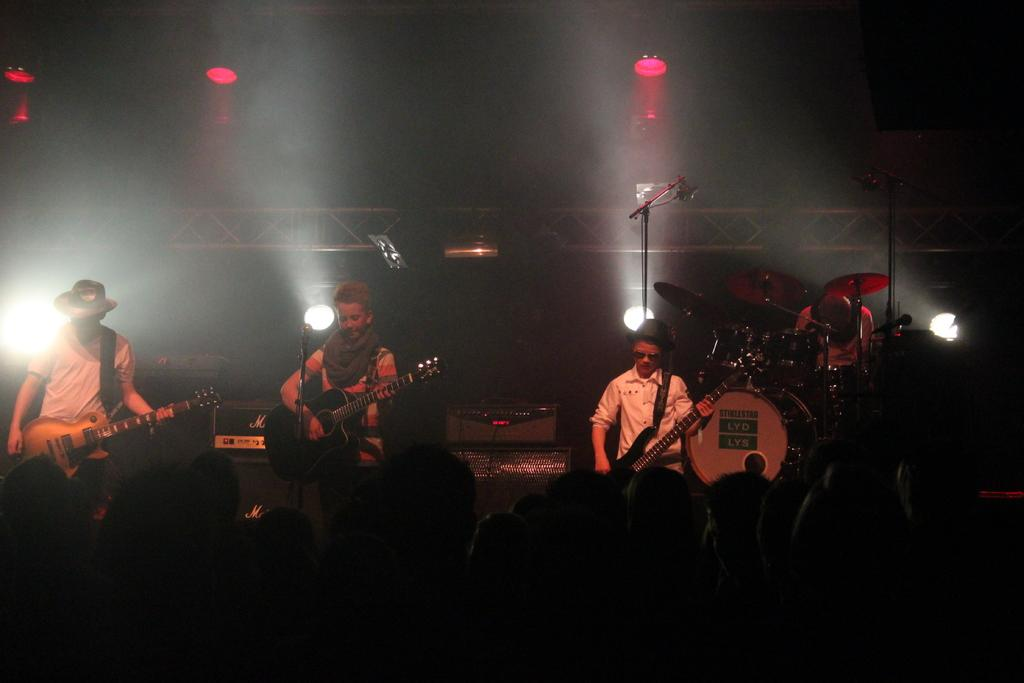How many people are in the image? There are three persons in the image. What are the persons holding in the image? The persons are holding guitars. What are the persons doing with the guitars? The persons are playing the guitars. Can you describe the presence of a microphone in the image? There is a microphone in front of one of the persons. What can be seen in the background of the image? There is a light visible in the background of the image. What type of plants can be seen growing near the persons in the image? There are no plants visible in the image; the focus is on the persons playing guitars and the presence of a microphone. 